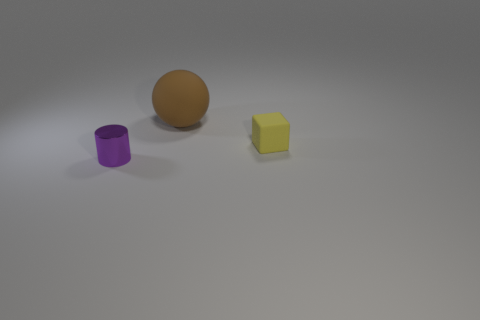Is there any other thing that has the same size as the brown matte sphere?
Your answer should be compact. No. What is the size of the object that is in front of the small thing that is right of the small metallic object?
Provide a succinct answer. Small. Are there an equal number of small matte objects that are on the left side of the sphere and purple metal cylinders behind the tiny yellow rubber cube?
Provide a succinct answer. Yes. How many other shiny cylinders have the same color as the small metallic cylinder?
Your response must be concise. 0. Is the shape of the rubber thing that is in front of the large brown ball the same as  the big object?
Give a very brief answer. No. There is a tiny object that is behind the small object in front of the tiny object right of the small metallic cylinder; what shape is it?
Provide a short and direct response. Cube. What is the size of the block?
Your answer should be compact. Small. There is a tiny object that is the same material as the sphere; what is its color?
Your response must be concise. Yellow. How many large balls have the same material as the tiny cube?
Make the answer very short. 1. There is a cube; is its color the same as the small thing that is left of the big brown rubber sphere?
Make the answer very short. No. 